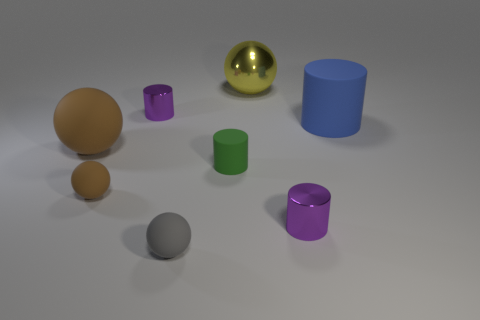How many tiny matte objects are right of the large shiny sphere to the right of the gray matte thing?
Provide a succinct answer. 0. Are there any green objects of the same shape as the blue matte object?
Offer a very short reply. Yes. Is the shape of the small metal thing behind the blue cylinder the same as the tiny purple thing that is to the right of the gray ball?
Ensure brevity in your answer.  Yes. There is a matte thing that is on the right side of the gray thing and to the left of the big yellow metal object; what is its shape?
Your answer should be compact. Cylinder. Are there any other metallic objects that have the same size as the gray thing?
Offer a very short reply. Yes. There is a large matte ball; is it the same color as the small rubber ball that is to the left of the small gray matte object?
Ensure brevity in your answer.  Yes. What is the yellow object made of?
Provide a short and direct response. Metal. What color is the ball that is behind the big blue cylinder?
Your response must be concise. Yellow. What number of small matte spheres have the same color as the large matte sphere?
Your response must be concise. 1. How many big things are in front of the big yellow shiny sphere and left of the big matte cylinder?
Your answer should be compact. 1. 